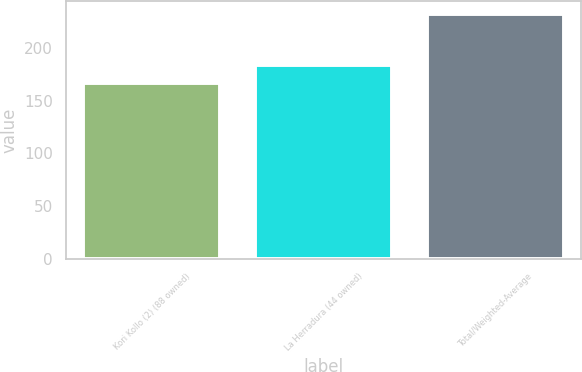<chart> <loc_0><loc_0><loc_500><loc_500><bar_chart><fcel>Kori Kollo (2) (88 owned)<fcel>La Herradura (44 owned)<fcel>Total/Weighted-Average<nl><fcel>167<fcel>184<fcel>233<nl></chart> 